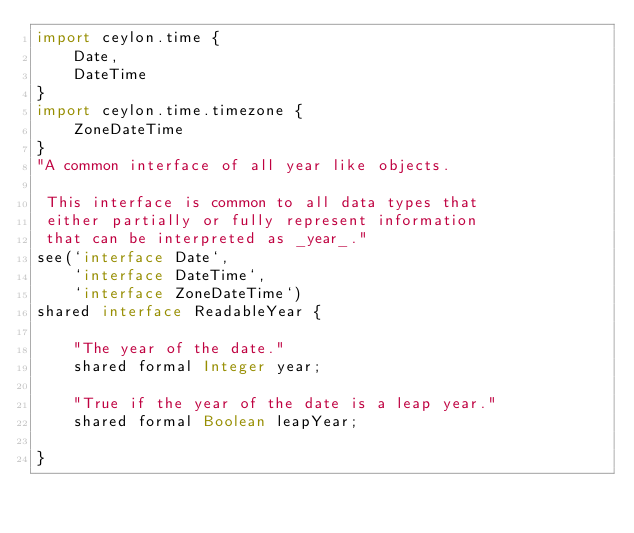<code> <loc_0><loc_0><loc_500><loc_500><_Ceylon_>import ceylon.time {
    Date,
    DateTime
}
import ceylon.time.timezone {
    ZoneDateTime
}
"A common interface of all year like objects.
 
 This interface is common to all data types that
 either partially or fully represent information 
 that can be interpreted as _year_."
see(`interface Date`,
    `interface DateTime`,
    `interface ZoneDateTime`)
shared interface ReadableYear {
    
    "The year of the date."
    shared formal Integer year;
    
    "True if the year of the date is a leap year."
    shared formal Boolean leapYear;
    
}</code> 